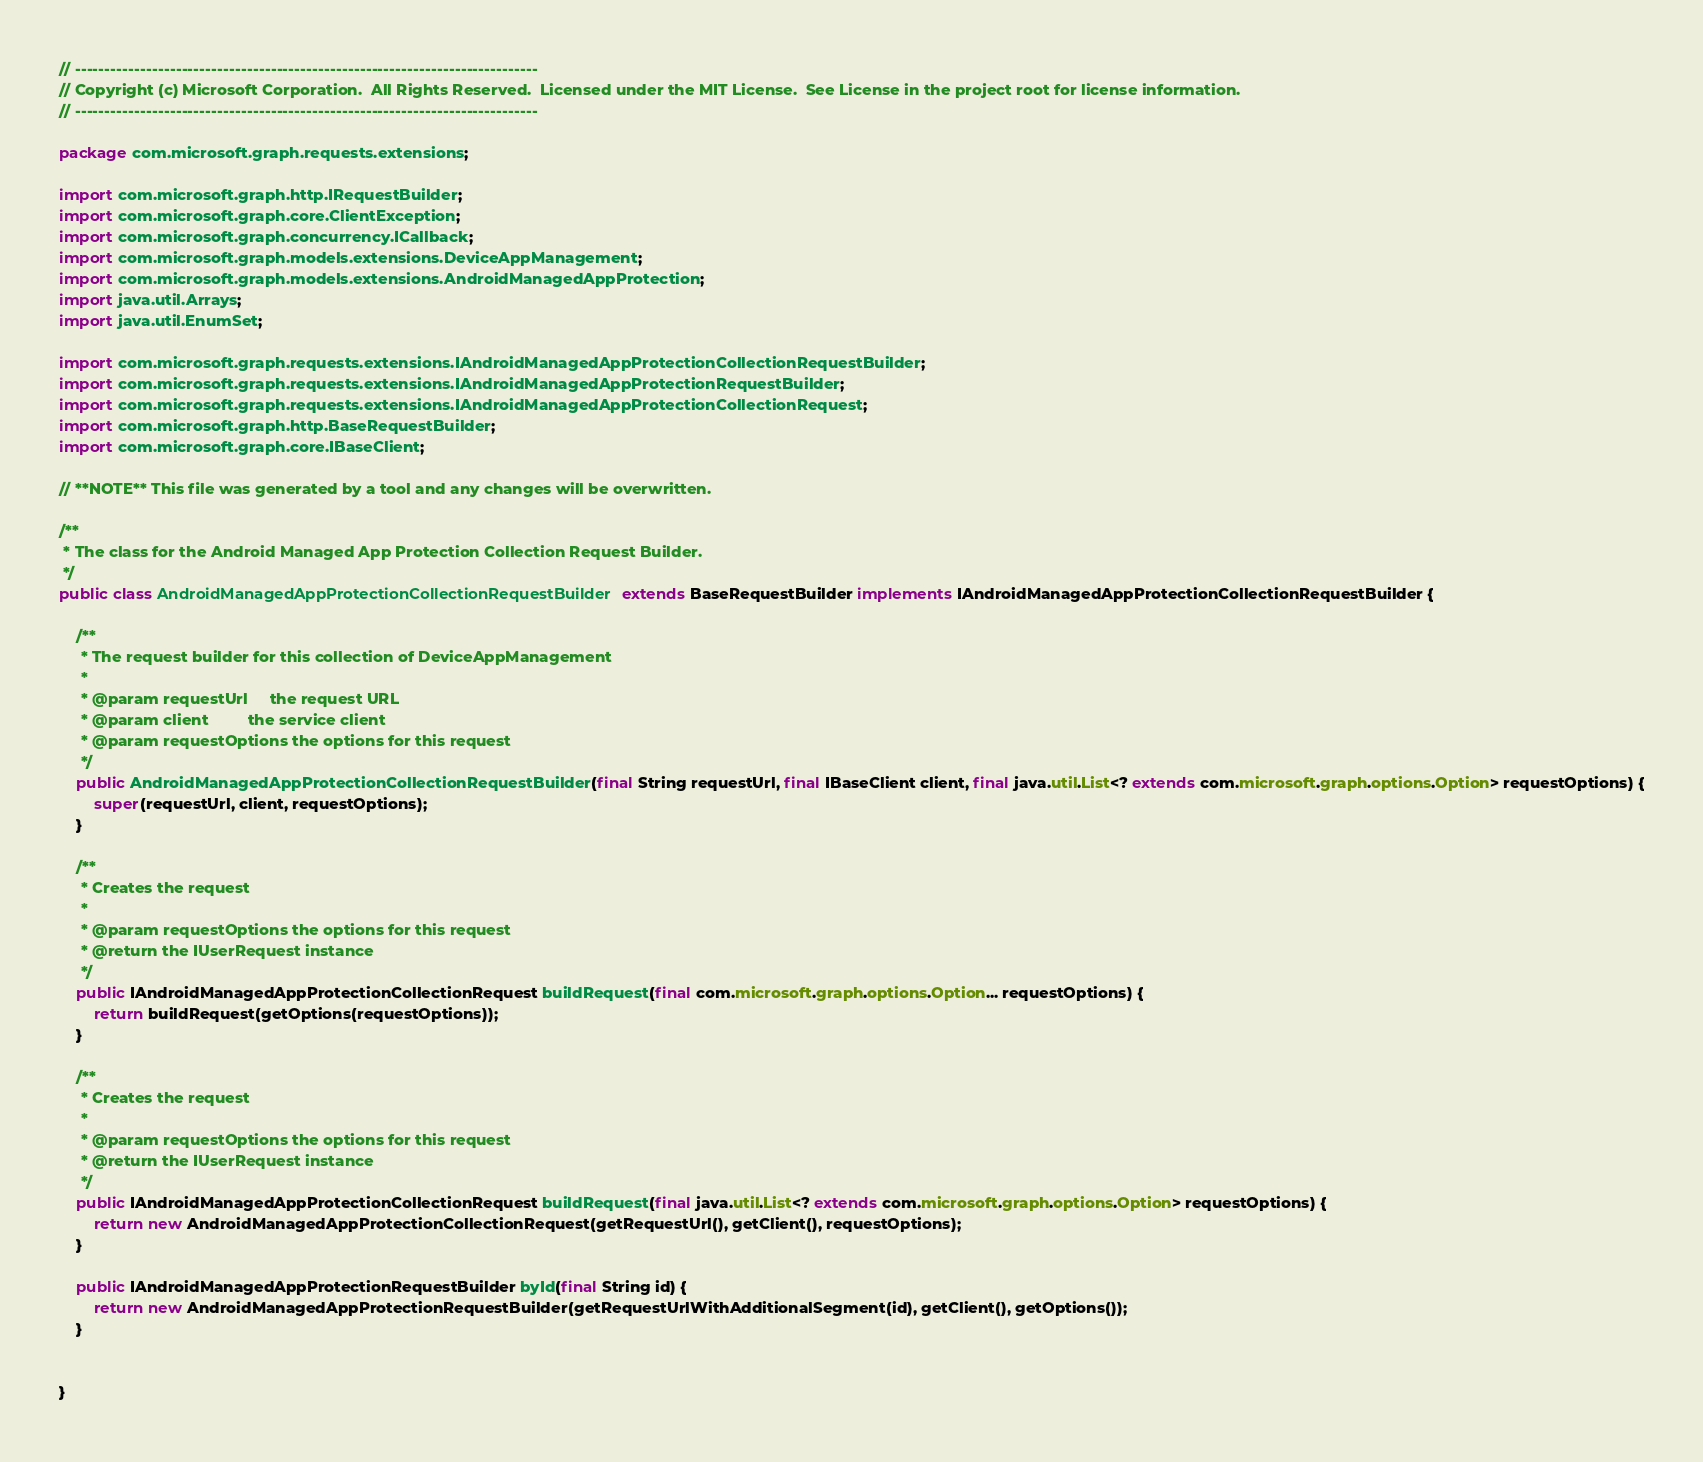<code> <loc_0><loc_0><loc_500><loc_500><_Java_>// ------------------------------------------------------------------------------
// Copyright (c) Microsoft Corporation.  All Rights Reserved.  Licensed under the MIT License.  See License in the project root for license information.
// ------------------------------------------------------------------------------

package com.microsoft.graph.requests.extensions;

import com.microsoft.graph.http.IRequestBuilder;
import com.microsoft.graph.core.ClientException;
import com.microsoft.graph.concurrency.ICallback;
import com.microsoft.graph.models.extensions.DeviceAppManagement;
import com.microsoft.graph.models.extensions.AndroidManagedAppProtection;
import java.util.Arrays;
import java.util.EnumSet;

import com.microsoft.graph.requests.extensions.IAndroidManagedAppProtectionCollectionRequestBuilder;
import com.microsoft.graph.requests.extensions.IAndroidManagedAppProtectionRequestBuilder;
import com.microsoft.graph.requests.extensions.IAndroidManagedAppProtectionCollectionRequest;
import com.microsoft.graph.http.BaseRequestBuilder;
import com.microsoft.graph.core.IBaseClient;

// **NOTE** This file was generated by a tool and any changes will be overwritten.

/**
 * The class for the Android Managed App Protection Collection Request Builder.
 */
public class AndroidManagedAppProtectionCollectionRequestBuilder extends BaseRequestBuilder implements IAndroidManagedAppProtectionCollectionRequestBuilder {

    /**
     * The request builder for this collection of DeviceAppManagement
     *
     * @param requestUrl     the request URL
     * @param client         the service client
     * @param requestOptions the options for this request
     */
    public AndroidManagedAppProtectionCollectionRequestBuilder(final String requestUrl, final IBaseClient client, final java.util.List<? extends com.microsoft.graph.options.Option> requestOptions) {
        super(requestUrl, client, requestOptions);
    }

    /**
     * Creates the request
     *
     * @param requestOptions the options for this request
     * @return the IUserRequest instance
     */
    public IAndroidManagedAppProtectionCollectionRequest buildRequest(final com.microsoft.graph.options.Option... requestOptions) {
        return buildRequest(getOptions(requestOptions));
    }

    /**
     * Creates the request
     *
     * @param requestOptions the options for this request
     * @return the IUserRequest instance
     */
    public IAndroidManagedAppProtectionCollectionRequest buildRequest(final java.util.List<? extends com.microsoft.graph.options.Option> requestOptions) {
        return new AndroidManagedAppProtectionCollectionRequest(getRequestUrl(), getClient(), requestOptions);
    }

    public IAndroidManagedAppProtectionRequestBuilder byId(final String id) {
        return new AndroidManagedAppProtectionRequestBuilder(getRequestUrlWithAdditionalSegment(id), getClient(), getOptions());
    }


}
</code> 